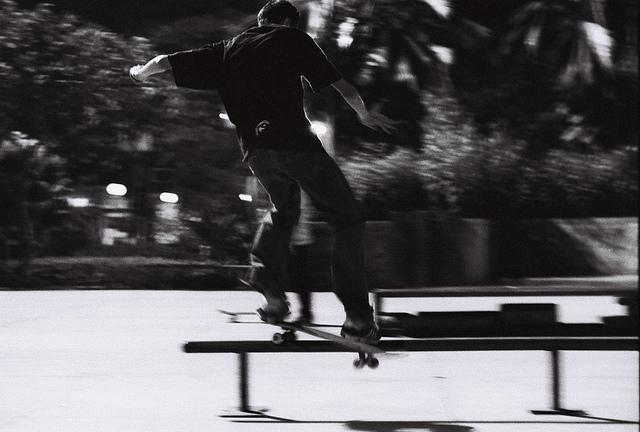How many benches are visible?
Give a very brief answer. 3. 